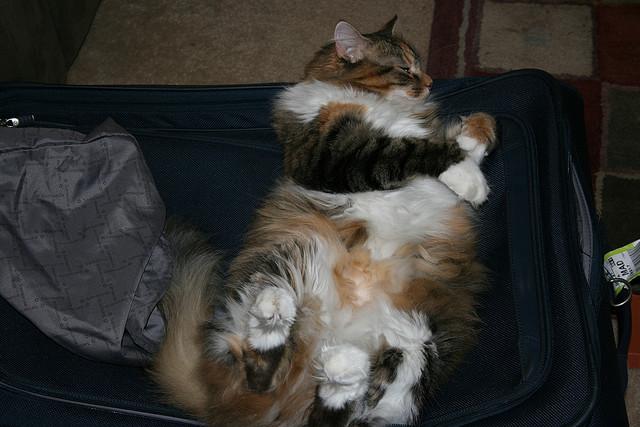How many cats are visible in the picture?
Write a very short answer. 1. Does the cat have kittens?
Keep it brief. No. What is the cat doing?
Quick response, please. Sleeping. 